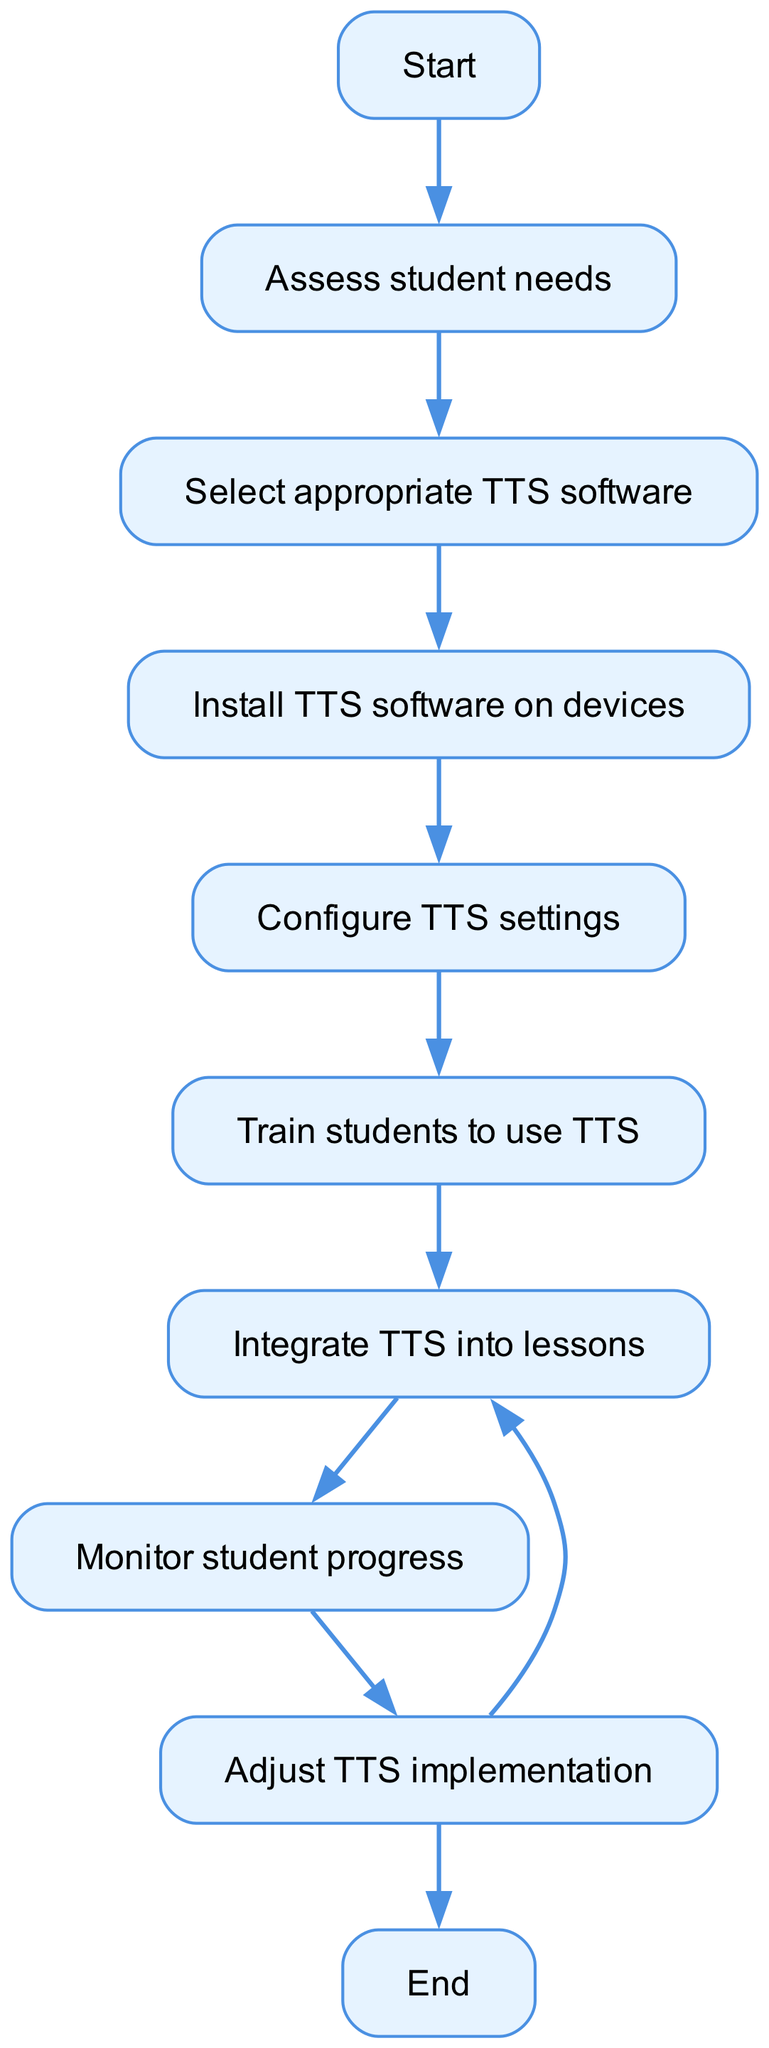What is the first step in the flowchart? The flowchart begins with the "Start" node, indicating that this is the initial action to be undertaken.
Answer: Start How many nodes are there in the flowchart? There are ten nodes listed in the diagram, which include various steps in the text-to-speech implementation process.
Answer: Ten What is the last step before ending the process? The last step before reaching the "End" node is "Adjust TTS implementation," which shows the need for evaluation before concluding.
Answer: Adjust TTS implementation Which node comes directly after "Monitor student progress"? The node that follows "Monitor student progress" is "Adjust TTS implementation," indicating that monitoring leads to adjustments if necessary.
Answer: Adjust TTS implementation Are there any loops in the flowchart? Yes, there is a loop where after "Adjust TTS implementation," one can return to "Integrate TTS into lessons," suggesting ongoing refinement.
Answer: Yes What is the relationship between "Train students to use TTS" and "Integrate TTS into lessons"? "Train students to use TTS" directly leads to "Integrate TTS into lessons," indicating that training is a prerequisite for integration.
Answer: Train leads to Integrate What is the purpose of assessing student needs? Assessing student needs is the first step of the flowchart, aimed at understanding what specific requirements must be addressed before implementing TTS.
Answer: Understand requirements How many edges are present in the flowchart? There are nine edges in total, representing the connections between all the nodes in the flowchart.
Answer: Nine What step occurs after selecting appropriate TTS software? The step that follows "Select appropriate TTS software" is "Install TTS software on devices," indicating that selection leads to installation.
Answer: Install TTS software on devices 